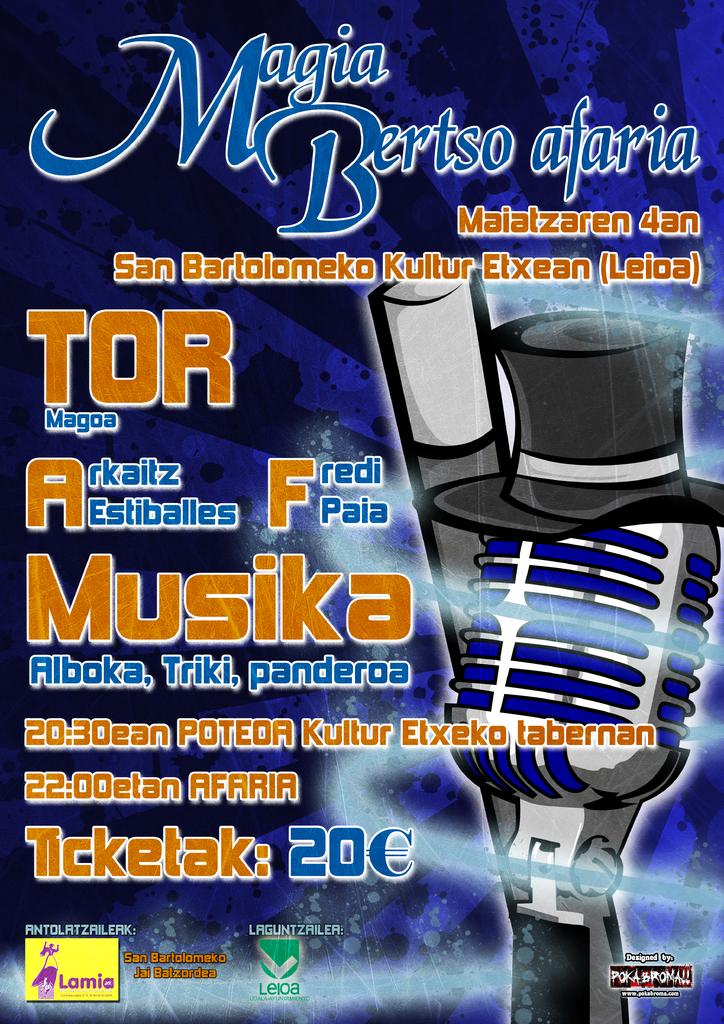Provide a one-sentence caption for the provided image. A poster advertising Magia Bertso afaria was designed by Pokabroma. 